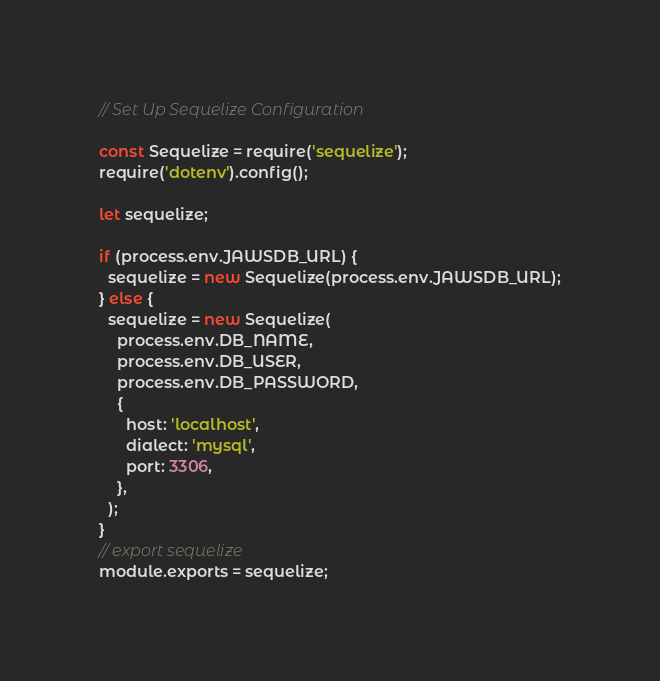<code> <loc_0><loc_0><loc_500><loc_500><_JavaScript_>// Set Up Sequelize Configuration

const Sequelize = require('sequelize');
require('dotenv').config();

let sequelize;

if (process.env.JAWSDB_URL) {
  sequelize = new Sequelize(process.env.JAWSDB_URL);
} else {
  sequelize = new Sequelize(
    process.env.DB_NAME,
    process.env.DB_USER,
    process.env.DB_PASSWORD,
    {
      host: 'localhost',
      dialect: 'mysql',
      port: 3306,
    },
  );
}
// export sequelize
module.exports = sequelize;
</code> 